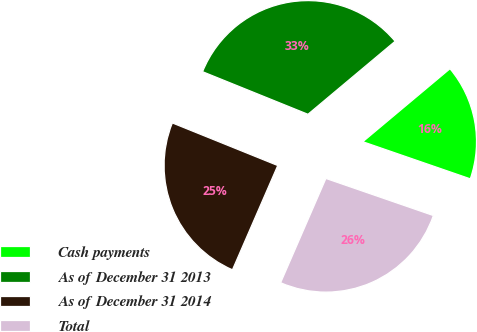<chart> <loc_0><loc_0><loc_500><loc_500><pie_chart><fcel>Cash payments<fcel>As of December 31 2013<fcel>As of December 31 2014<fcel>Total<nl><fcel>16.39%<fcel>32.79%<fcel>24.59%<fcel>26.23%<nl></chart> 